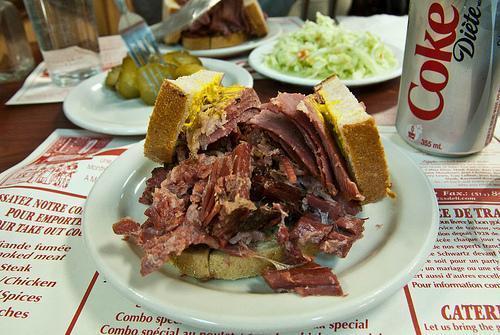How many drinks are shown?
Give a very brief answer. 2. 